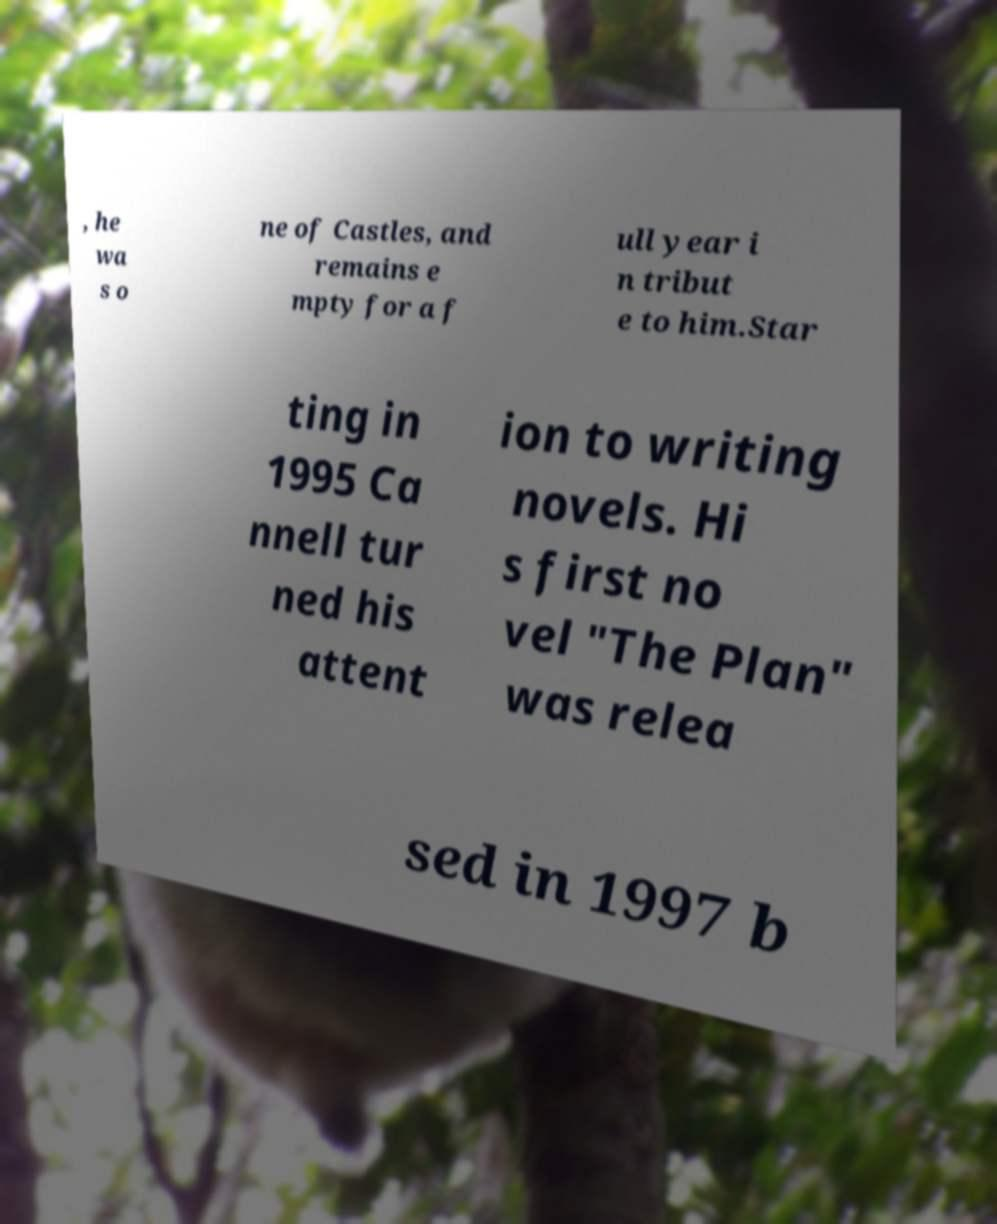Could you extract and type out the text from this image? , he wa s o ne of Castles, and remains e mpty for a f ull year i n tribut e to him.Star ting in 1995 Ca nnell tur ned his attent ion to writing novels. Hi s first no vel "The Plan" was relea sed in 1997 b 